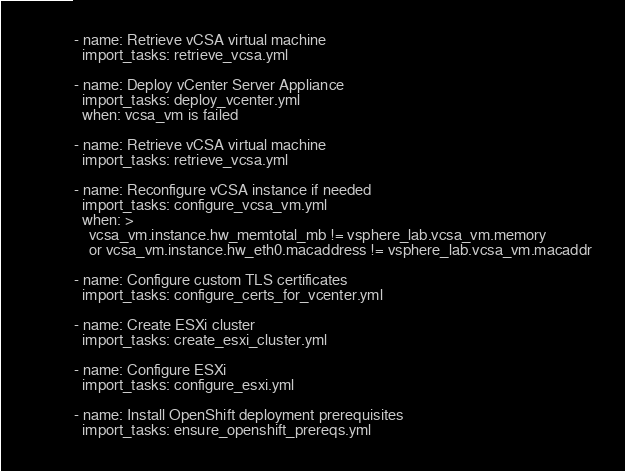<code> <loc_0><loc_0><loc_500><loc_500><_YAML_>- name: Retrieve vCSA virtual machine
  import_tasks: retrieve_vcsa.yml

- name: Deploy vCenter Server Appliance
  import_tasks: deploy_vcenter.yml
  when: vcsa_vm is failed

- name: Retrieve vCSA virtual machine
  import_tasks: retrieve_vcsa.yml

- name: Reconfigure vCSA instance if needed
  import_tasks: configure_vcsa_vm.yml
  when: >
    vcsa_vm.instance.hw_memtotal_mb != vsphere_lab.vcsa_vm.memory
    or vcsa_vm.instance.hw_eth0.macaddress != vsphere_lab.vcsa_vm.macaddr

- name: Configure custom TLS certificates
  import_tasks: configure_certs_for_vcenter.yml

- name: Create ESXi cluster
  import_tasks: create_esxi_cluster.yml

- name: Configure ESXi
  import_tasks: configure_esxi.yml

- name: Install OpenShift deployment prerequisites
  import_tasks: ensure_openshift_prereqs.yml
</code> 